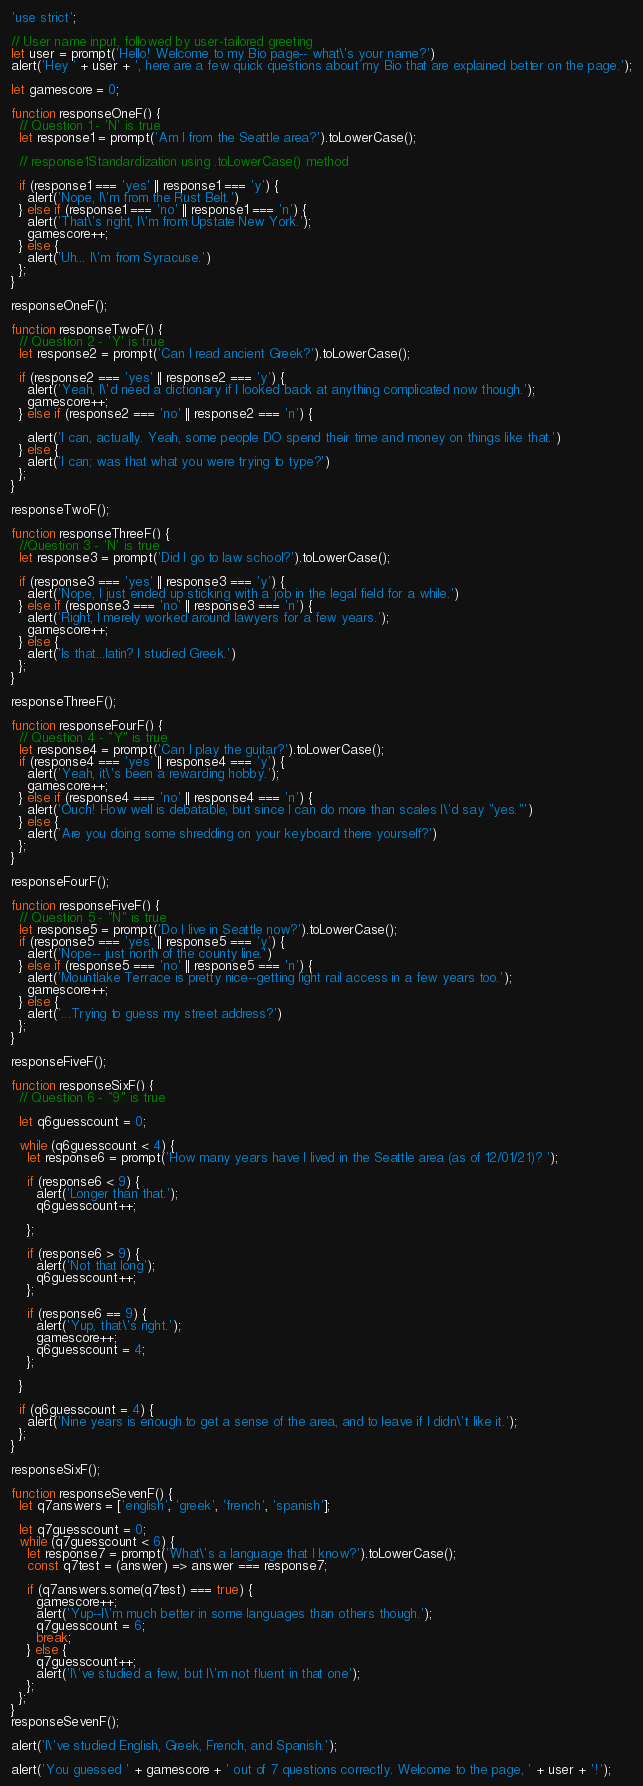<code> <loc_0><loc_0><loc_500><loc_500><_JavaScript_>'use strict';

// User name input, followed by user-tailored greeting
let user = prompt('Hello! Welcome to my Bio page-- what\'s your name?')
alert('Hey ' + user + ', here are a few quick questions about my Bio that are explained better on the page.');

let gamescore = 0;

function responseOneF() {
  // Question 1 - 'N' is true
  let response1 = prompt('Am I from the Seattle area?').toLowerCase();

  // response1Standardization using .toLowerCase() method

  if (response1 === 'yes' || response1 === 'y') {
    alert('Nope, I\'m from the Rust Belt.')
  } else if (response1 === 'no' || response1 === 'n') {
    alert('That\'s right, I\'m from Upstate New York.');
    gamescore++;
  } else {
    alert('Uh... I\'m from Syracuse.')
  };
}

responseOneF();

function responseTwoF() {
  // Question 2 - 'Y' is true
  let response2 = prompt('Can I read ancient Greek?').toLowerCase();

  if (response2 === 'yes' || response2 === 'y') {
    alert('Yeah, I\'d need a dictionary if I looked back at anything complicated now though.');
    gamescore++;
  } else if (response2 === 'no' || response2 === 'n') {

    alert('I can, actually. Yeah, some people DO spend their time and money on things like that.')
  } else {
    alert('I can; was that what you were trying to type?')
  };
}

responseTwoF();

function responseThreeF() {
  //Question 3 - 'N' is true
  let response3 = prompt('Did I go to law school?').toLowerCase();

  if (response3 === 'yes' || response3 === 'y') {
    alert('Nope, I just ended up sticking with a job in the legal field for a while.')
  } else if (response3 === 'no' || response3 === 'n') {
    alert('Right, I merely worked around lawyers for a few years.');
    gamescore++;
  } else {
    alert('Is that...latin? I studied Greek.')
  };
}

responseThreeF();

function responseFourF() {
  // Question 4 - "Y" is true
  let response4 = prompt('Can I play the guitar?').toLowerCase();
  if (response4 === 'yes' || response4 === 'y') {
    alert('Yeah, it\'s been a rewarding hobby.');
    gamescore++;
  } else if (response4 === 'no' || response4 === 'n') {
    alert('Ouch! How well is debatable, but since I can do more than scales I\'d say "yes."')
  } else {
    alert('Are you doing some shredding on your keyboard there yourself?')
  };
}

responseFourF();

function responseFiveF() {
  // Question 5 - "N" is true
  let response5 = prompt('Do I live in Seattle now?').toLowerCase();
  if (response5 === 'yes' || response5 === 'y') {
    alert('Nope-- just north of the county line.')
  } else if (response5 === 'no' || response5 === 'n') {
    alert('Mountlake Terrace is pretty nice--getting light rail access in a few years too.');
    gamescore++;
  } else {
    alert('...Trying to guess my street address?')
  };
}

responseFiveF();

function responseSixF() {
  // Question 6 - "9" is true

  let q6guesscount = 0;

  while (q6guesscount < 4) {
    let response6 = prompt('How many years have I lived in the Seattle area (as of 12/01/21)? ');

    if (response6 < 9) {
      alert('Longer than that.');
      q6guesscount++;

    };

    if (response6 > 9) {
      alert('Not that long');
      q6guesscount++;
    };

    if (response6 == 9) {
      alert('Yup, that\'s right.');
      gamescore++;
      q6guesscount = 4;
    };

  }

  if (q6guesscount = 4) {
    alert('Nine years is enough to get a sense of the area, and to leave if I didn\'t like it.');
  };
}

responseSixF();

function responseSevenF() {
  let q7answers = ['english', 'greek', 'french', 'spanish'];

  let q7guesscount = 0;
  while (q7guesscount < 6) {
    let response7 = prompt('What\'s a language that I know?').toLowerCase();
    const q7test = (answer) => answer === response7;

    if (q7answers.some(q7test) === true) {
      gamescore++;
      alert('Yup--I\'m much better in some languages than others though.');
      q7guesscount = 6;
      break;
    } else {
      q7guesscount++;
      alert('I\'ve studied a few, but I\'m not fluent in that one');
    };
  };
}
responseSevenF();

alert('I\'ve studied English, Greek, French, and Spanish.');

alert('You guessed ' + gamescore + ' out of 7 questions correctly. Welcome to the page, ' + user + '!');
</code> 